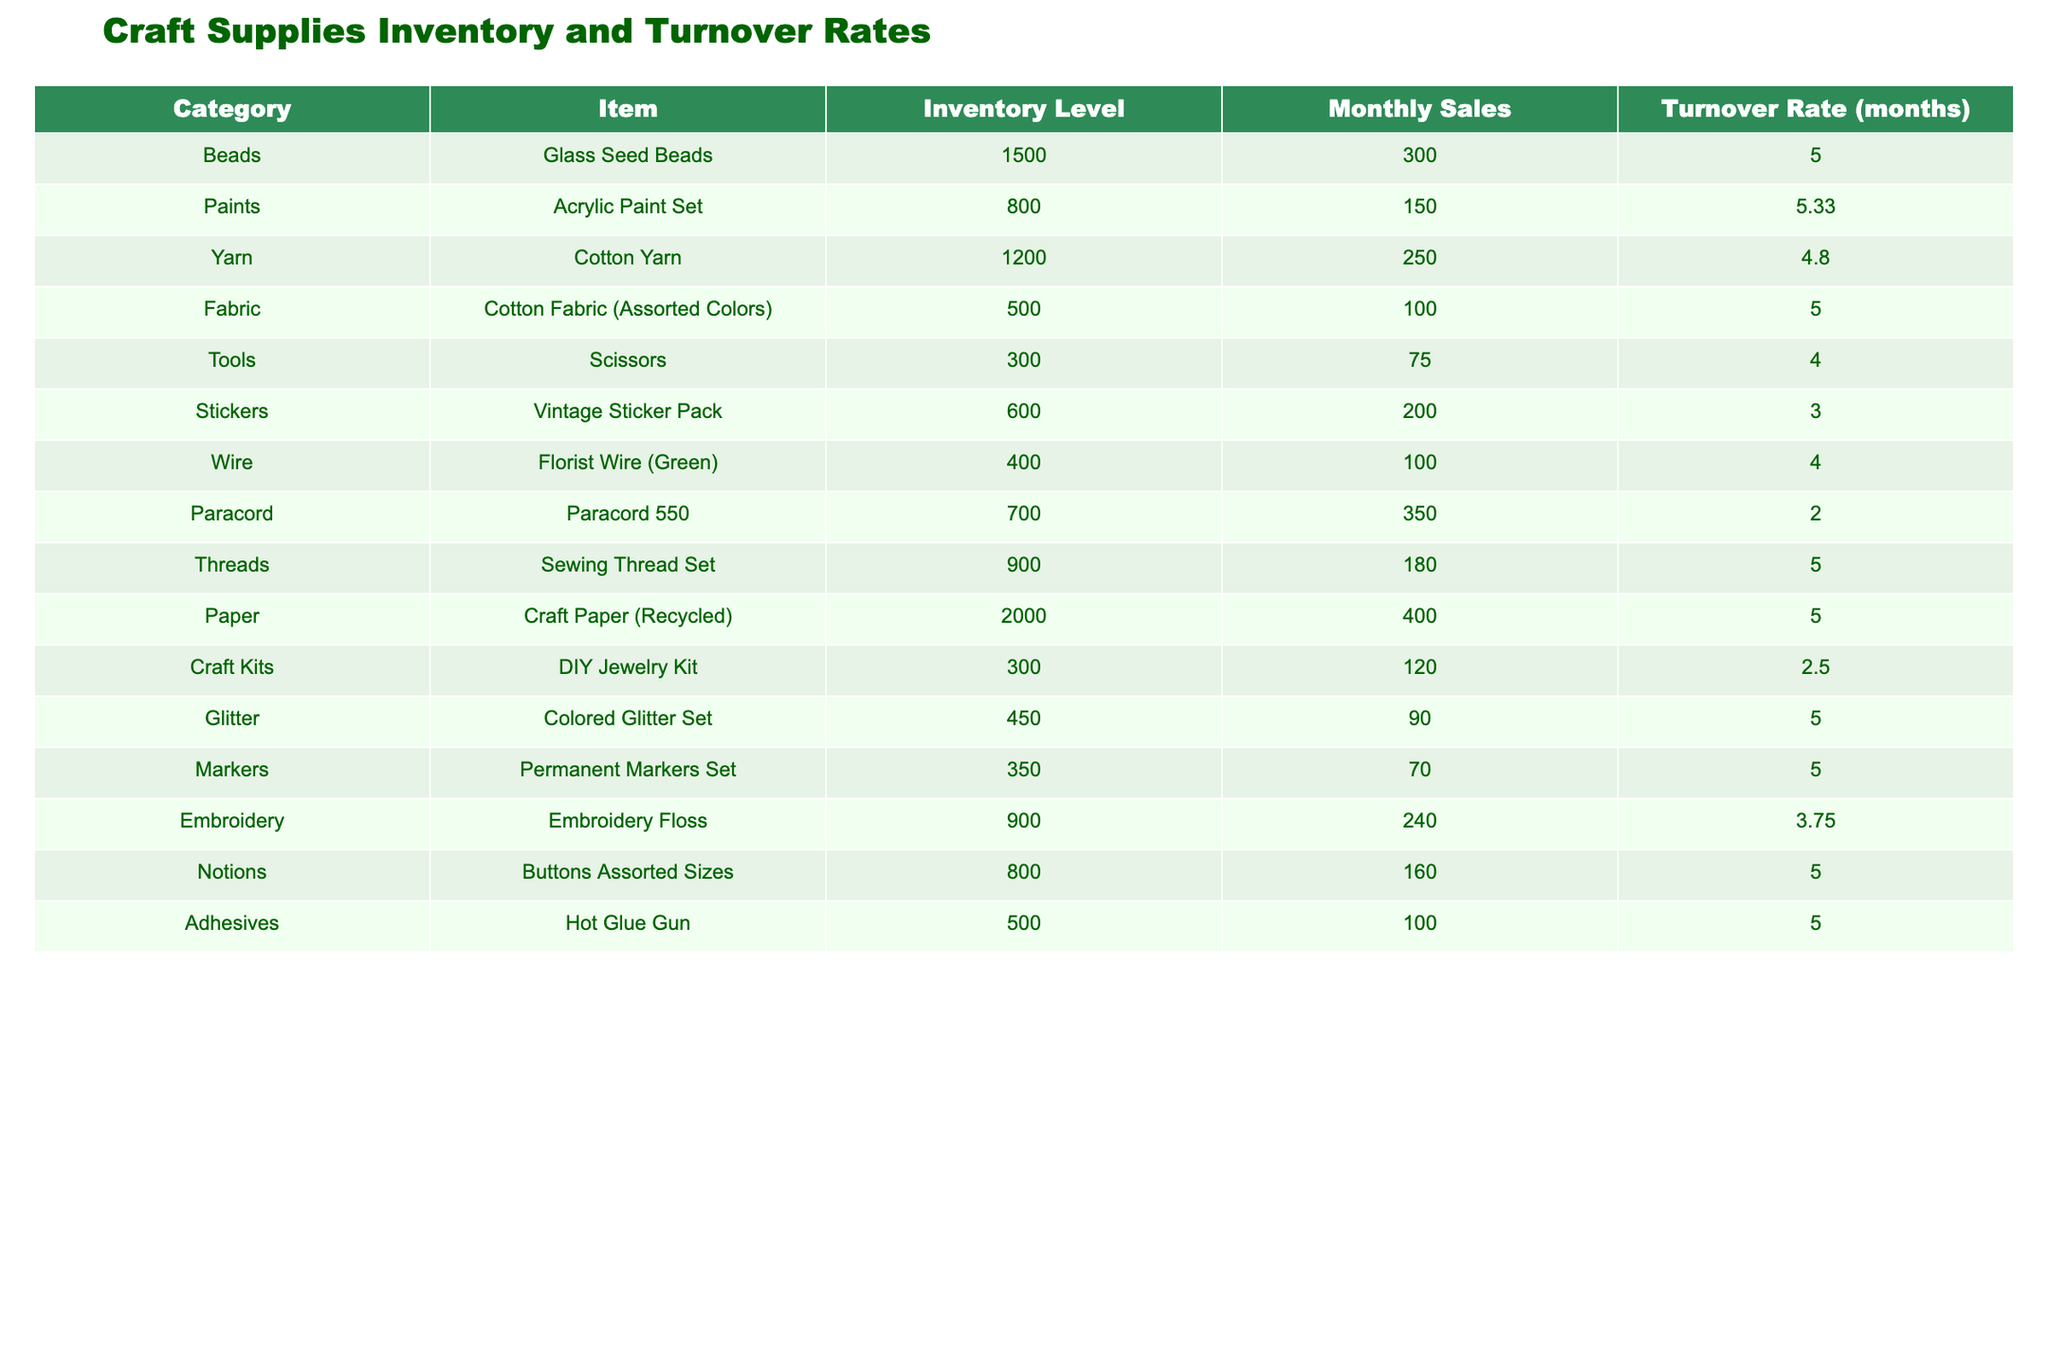What is the inventory level of Glass Seed Beads? The inventory level for Glass Seed Beads is listed directly in the table under the "Inventory Level" column. The value for Glass Seed Beads is 1500.
Answer: 1500 What is the turnover rate for Acrylic Paint Set? The turnover rate for the Acrylic Paint Set can be found in the table under the "Turnover Rate (months)" column. The value for Acrylic Paint Set is 5.33 months.
Answer: 5.33 How many items have an inventory level of 800 or more? To find this, we check the inventory levels in the table. The items with inventory levels of 800 or more are Glass Seed Beads (1500), Acrylic Paint Set (800), Cotton Yarn (1200), Cotton Fabric (Assorted Colors) (500), Buttons Assorted Sizes (800), and Hot Glue Gun (500). This sums up to 5 items.
Answer: 5 What is the average turnover rate of all items? To calculate the average turnover rate, we sum up all the turnover rates: (5 + 5.33 + 4.8 + 5 + 4 + 3 + 4 + 2 + 5 + 2.5 + 5 + 5 + 3.75 + 5 + 5) = 57.38. Since there are 15 items, we divide by 15: 57.38 / 15 = 3.82.
Answer: 3.82 Is the monthly sales of Paracord higher than that of Vintage Sticker Pack? The monthly sales for Paracord is 350, and for Vintage Sticker Pack, it is 200. Since 350 is greater than 200, the statement is true.
Answer: Yes Which item has the lowest turnover rate? By examining the turnover rates in the table, the lowest rate is for the Paracord with a turnover rate of 2 months.
Answer: Paracord What is the total inventory level of all crafting supplies? To find the total inventory, add up all the inventory levels: (1500 + 800 + 1200 + 500 + 300 + 600 + 400 + 700 + 900 + 2000 + 300 + 450 + 350 + 900 + 800 + 500) = 11900.
Answer: 11900 How many items have a turnover rate of less than 4 months? From the table, we see the items with turnover rates below 4 months are: Paracord (2), DIY Jewelry Kit (2.5), and Vintage Sticker Pack (3), which gives a total of 3 items.
Answer: 3 What is the difference in inventory level between the highest and lowest inventory items? The highest inventory item is Craft Paper (Recycled) with 2000 units, and the lowest is Scissors with 300 units. The difference is 2000 - 300 = 1700.
Answer: 1700 